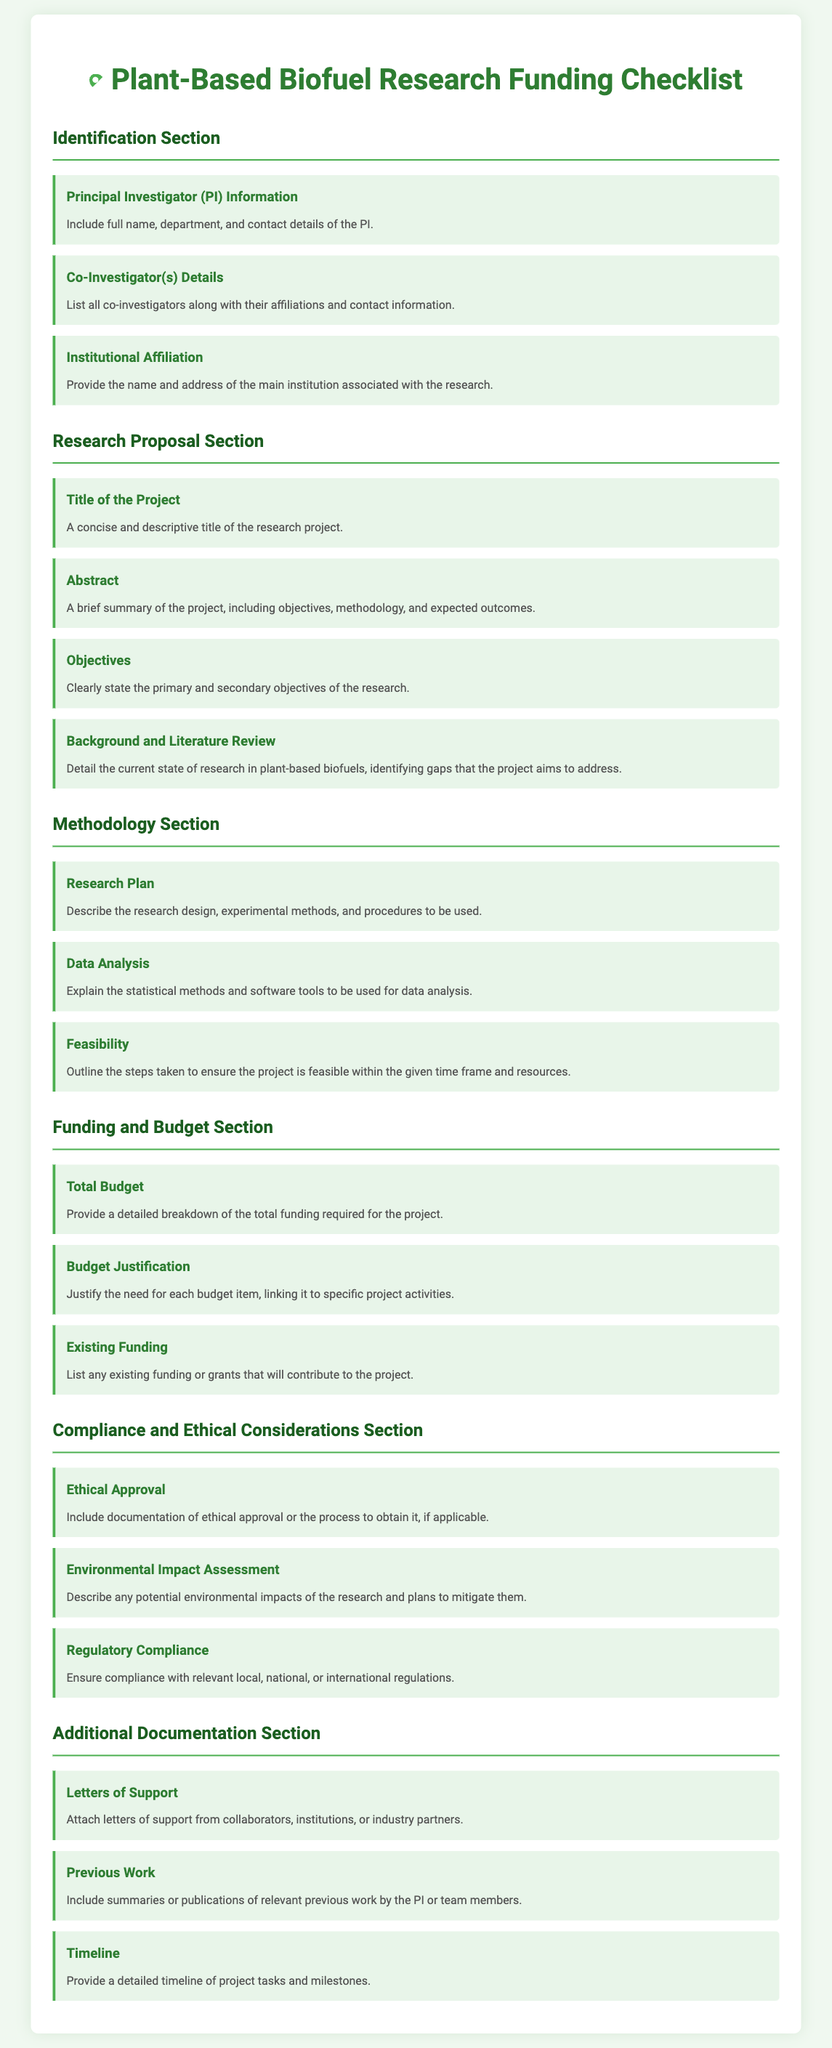What is required in the Principal Investigator Information? The Principal Investigator Information must include the full name, department, and contact details of the PI.
Answer: Full name, department, and contact details What should be included in the Budget Justification? The Budget Justification requires justification for each budget item, linking it to specific project activities.
Answer: Justification for each budget item What is the main focus of the Background and Literature Review? This section should detail the current state of research in plant-based biofuels, identifying gaps the project aims to address.
Answer: Current state of research and identify gaps How many sections are there in the checklist? The document has five main sections addressing different aspects of the funding application requirements.
Answer: Five What types of support letters should be attached? The document specifies the need to attach letters of support from collaborators, institutions, or industry partners.
Answer: Collaborators, institutions, or industry partners What is the purpose of the Environmental Impact Assessment? The Environmental Impact Assessment must describe any potential environmental impacts of the research and plans to mitigate them.
Answer: Describe potential environmental impacts What does the Timeline include? The Timeline includes a detailed timeline of project tasks and milestones.
Answer: Detailed timeline of project tasks What is stated in the Total Budget section? The Total Budget section requires a detailed breakdown of the total funding required for the project.
Answer: Detailed breakdown of total funding required 